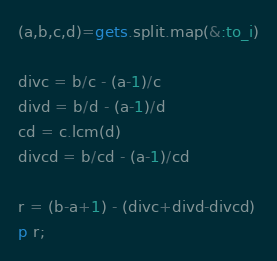<code> <loc_0><loc_0><loc_500><loc_500><_Ruby_>(a,b,c,d)=gets.split.map(&:to_i)

divc = b/c - (a-1)/c
divd = b/d - (a-1)/d
cd = c.lcm(d)
divcd = b/cd - (a-1)/cd

r = (b-a+1) - (divc+divd-divcd)
p r;</code> 